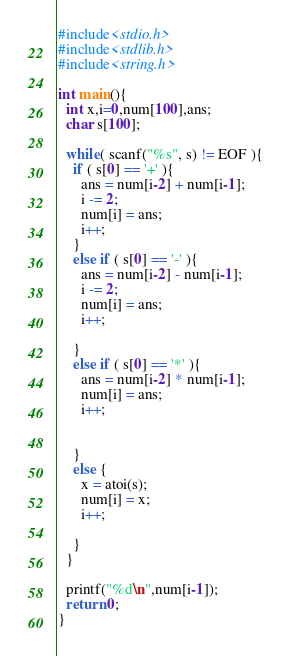Convert code to text. <code><loc_0><loc_0><loc_500><loc_500><_C_>#include<stdio.h>
#include<stdlib.h>
#include<string.h>

int main(){
  int x,i=0,num[100],ans;
  char s[100];

  while( scanf("%s", s) != EOF ){
    if ( s[0] == '+' ){
      ans = num[i-2] + num[i-1];
      i -= 2;
      num[i] = ans;
      i++;
    }
    else if ( s[0] == '-' ){
      ans = num[i-2] - num[i-1];
      i -= 2;
      num[i] = ans;
      i++;

    }
    else if ( s[0] == '*' ){
      ans = num[i-2] * num[i-1];
      num[i] = ans;
      i++;

      
    }
    else {
      x = atoi(s);
      num[i] = x;
      i++;
      
    }
  }
  
  printf("%d\n",num[i-1]);
  return 0;
}</code> 